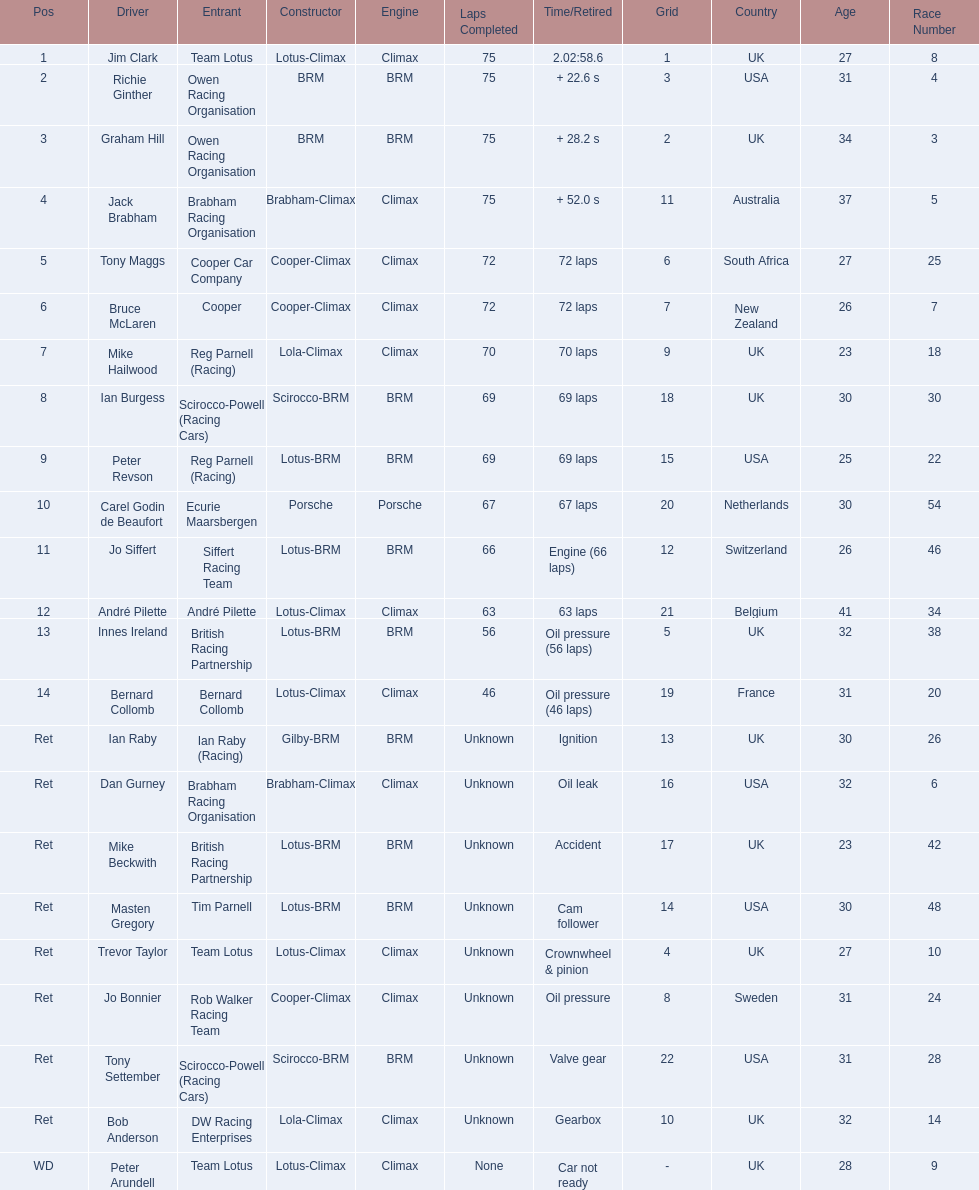Who are all the drivers? Jim Clark, Richie Ginther, Graham Hill, Jack Brabham, Tony Maggs, Bruce McLaren, Mike Hailwood, Ian Burgess, Peter Revson, Carel Godin de Beaufort, Jo Siffert, André Pilette, Innes Ireland, Bernard Collomb, Ian Raby, Dan Gurney, Mike Beckwith, Masten Gregory, Trevor Taylor, Jo Bonnier, Tony Settember, Bob Anderson, Peter Arundell. Could you parse the entire table? {'header': ['Pos', 'Driver', 'Entrant', 'Constructor', 'Engine', 'Laps Completed', 'Time/Retired', 'Grid', 'Country', 'Age', 'Race Number'], 'rows': [['1', 'Jim Clark', 'Team Lotus', 'Lotus-Climax', 'Climax', '75', '2.02:58.6', '1', 'UK', '27', '8'], ['2', 'Richie Ginther', 'Owen Racing Organisation', 'BRM', 'BRM', '75', '+ 22.6 s', '3', 'USA', '31', '4'], ['3', 'Graham Hill', 'Owen Racing Organisation', 'BRM', 'BRM', '75', '+ 28.2 s', '2', 'UK', '34', '3'], ['4', 'Jack Brabham', 'Brabham Racing Organisation', 'Brabham-Climax', 'Climax', '75', '+ 52.0 s', '11', 'Australia', '37', '5'], ['5', 'Tony Maggs', 'Cooper Car Company', 'Cooper-Climax', 'Climax', '72', '72 laps', '6', 'South Africa', '27', '25'], ['6', 'Bruce McLaren', 'Cooper', 'Cooper-Climax', 'Climax', '72', '72 laps', '7', 'New Zealand', '26', '7'], ['7', 'Mike Hailwood', 'Reg Parnell (Racing)', 'Lola-Climax', 'Climax', '70', '70 laps', '9', 'UK', '23', '18'], ['8', 'Ian Burgess', 'Scirocco-Powell (Racing Cars)', 'Scirocco-BRM', 'BRM', '69', '69 laps', '18', 'UK', '30', '30'], ['9', 'Peter Revson', 'Reg Parnell (Racing)', 'Lotus-BRM', 'BRM', '69', '69 laps', '15', 'USA', '25', '22'], ['10', 'Carel Godin de Beaufort', 'Ecurie Maarsbergen', 'Porsche', 'Porsche', '67', '67 laps', '20', 'Netherlands', '30', '54'], ['11', 'Jo Siffert', 'Siffert Racing Team', 'Lotus-BRM', 'BRM', '66', 'Engine (66 laps)', '12', 'Switzerland', '26', '46'], ['12', 'André Pilette', 'André Pilette', 'Lotus-Climax', 'Climax', '63', '63 laps', '21', 'Belgium', '41', '34'], ['13', 'Innes Ireland', 'British Racing Partnership', 'Lotus-BRM', 'BRM', '56', 'Oil pressure (56 laps)', '5', 'UK', '32', '38'], ['14', 'Bernard Collomb', 'Bernard Collomb', 'Lotus-Climax', 'Climax', '46', 'Oil pressure (46 laps)', '19', 'France', '31', '20'], ['Ret', 'Ian Raby', 'Ian Raby (Racing)', 'Gilby-BRM', 'BRM', 'Unknown', 'Ignition', '13', 'UK', '30', '26'], ['Ret', 'Dan Gurney', 'Brabham Racing Organisation', 'Brabham-Climax', 'Climax', 'Unknown', 'Oil leak', '16', 'USA', '32', '6'], ['Ret', 'Mike Beckwith', 'British Racing Partnership', 'Lotus-BRM', 'BRM', 'Unknown', 'Accident', '17', 'UK', '23', '42'], ['Ret', 'Masten Gregory', 'Tim Parnell', 'Lotus-BRM', 'BRM', 'Unknown', 'Cam follower', '14', 'USA', '30', '48'], ['Ret', 'Trevor Taylor', 'Team Lotus', 'Lotus-Climax', 'Climax', 'Unknown', 'Crownwheel & pinion', '4', 'UK', '27', '10'], ['Ret', 'Jo Bonnier', 'Rob Walker Racing Team', 'Cooper-Climax', 'Climax', 'Unknown', 'Oil pressure', '8', 'Sweden', '31', '24'], ['Ret', 'Tony Settember', 'Scirocco-Powell (Racing Cars)', 'Scirocco-BRM', 'BRM', 'Unknown', 'Valve gear', '22', 'USA', '31', '28'], ['Ret', 'Bob Anderson', 'DW Racing Enterprises', 'Lola-Climax', 'Climax', 'Unknown', 'Gearbox', '10', 'UK', '32', '14'], ['WD', 'Peter Arundell', 'Team Lotus', 'Lotus-Climax', 'Climax', 'None', 'Car not ready', '-', 'UK', '28', '9']]} What position were they in? 1, 2, 3, 4, 5, 6, 7, 8, 9, 10, 11, 12, 13, 14, Ret, Ret, Ret, Ret, Ret, Ret, Ret, Ret, WD. What about just tony maggs and jo siffert? 5, 11. And between them, which driver came in earlier? Tony Maggs. 